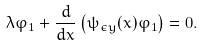<formula> <loc_0><loc_0><loc_500><loc_500>\lambda \varphi _ { 1 } + \frac { d } { d x } \left ( \psi _ { \epsilon y } ( x ) \varphi _ { 1 } \right ) = 0 .</formula> 